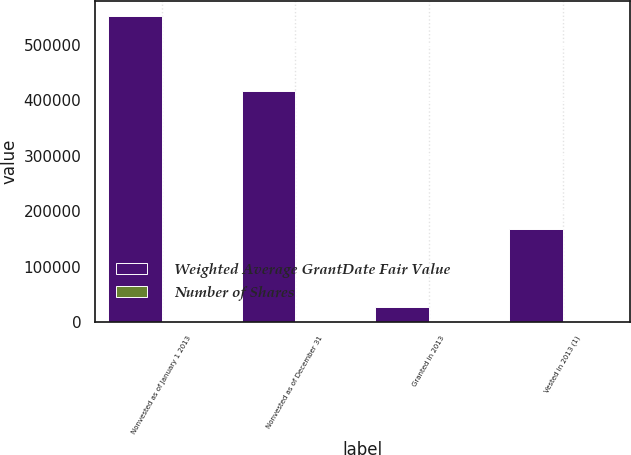Convert chart. <chart><loc_0><loc_0><loc_500><loc_500><stacked_bar_chart><ecel><fcel>Nonvested as of January 1 2013<fcel>Nonvested as of December 31<fcel>Granted in 2013<fcel>Vested in 2013 (1)<nl><fcel>Weighted Average GrantDate Fair Value<fcel>551678<fcel>417464<fcel>27561<fcel>167751<nl><fcel>Number of Shares<fcel>46.73<fcel>45.46<fcel>42.53<fcel>37.1<nl></chart> 